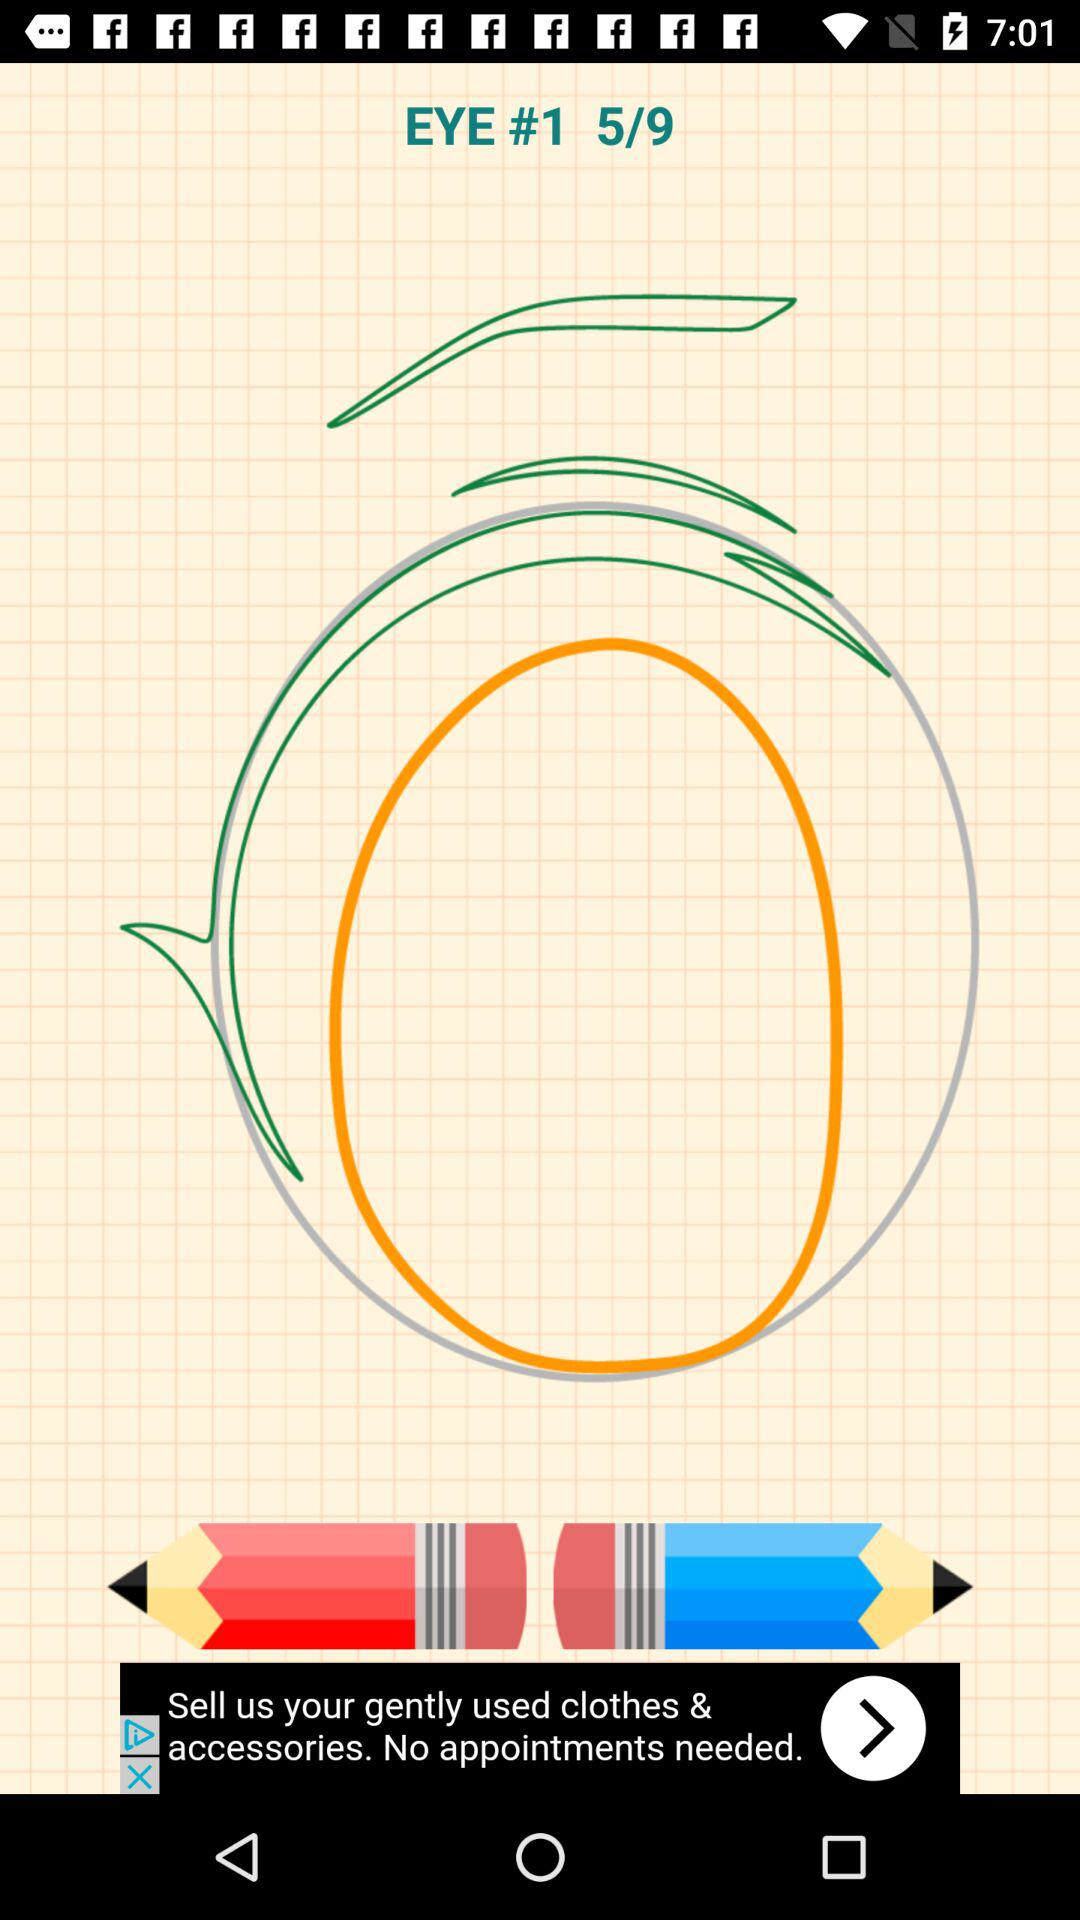What is the total number of pages? The total number of pages is 9. 